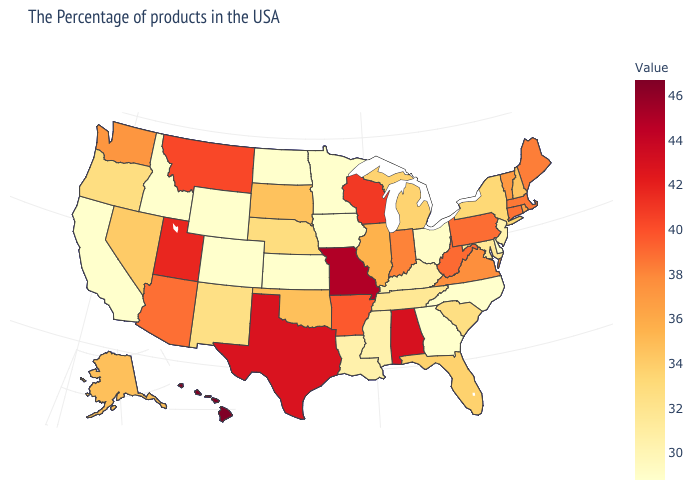Among the states that border Alabama , does Florida have the highest value?
Concise answer only. Yes. Is the legend a continuous bar?
Keep it brief. Yes. Does Rhode Island have the highest value in the Northeast?
Short answer required. No. Which states have the highest value in the USA?
Give a very brief answer. Hawaii. Which states have the highest value in the USA?
Keep it brief. Hawaii. Among the states that border Indiana , which have the highest value?
Answer briefly. Illinois. 